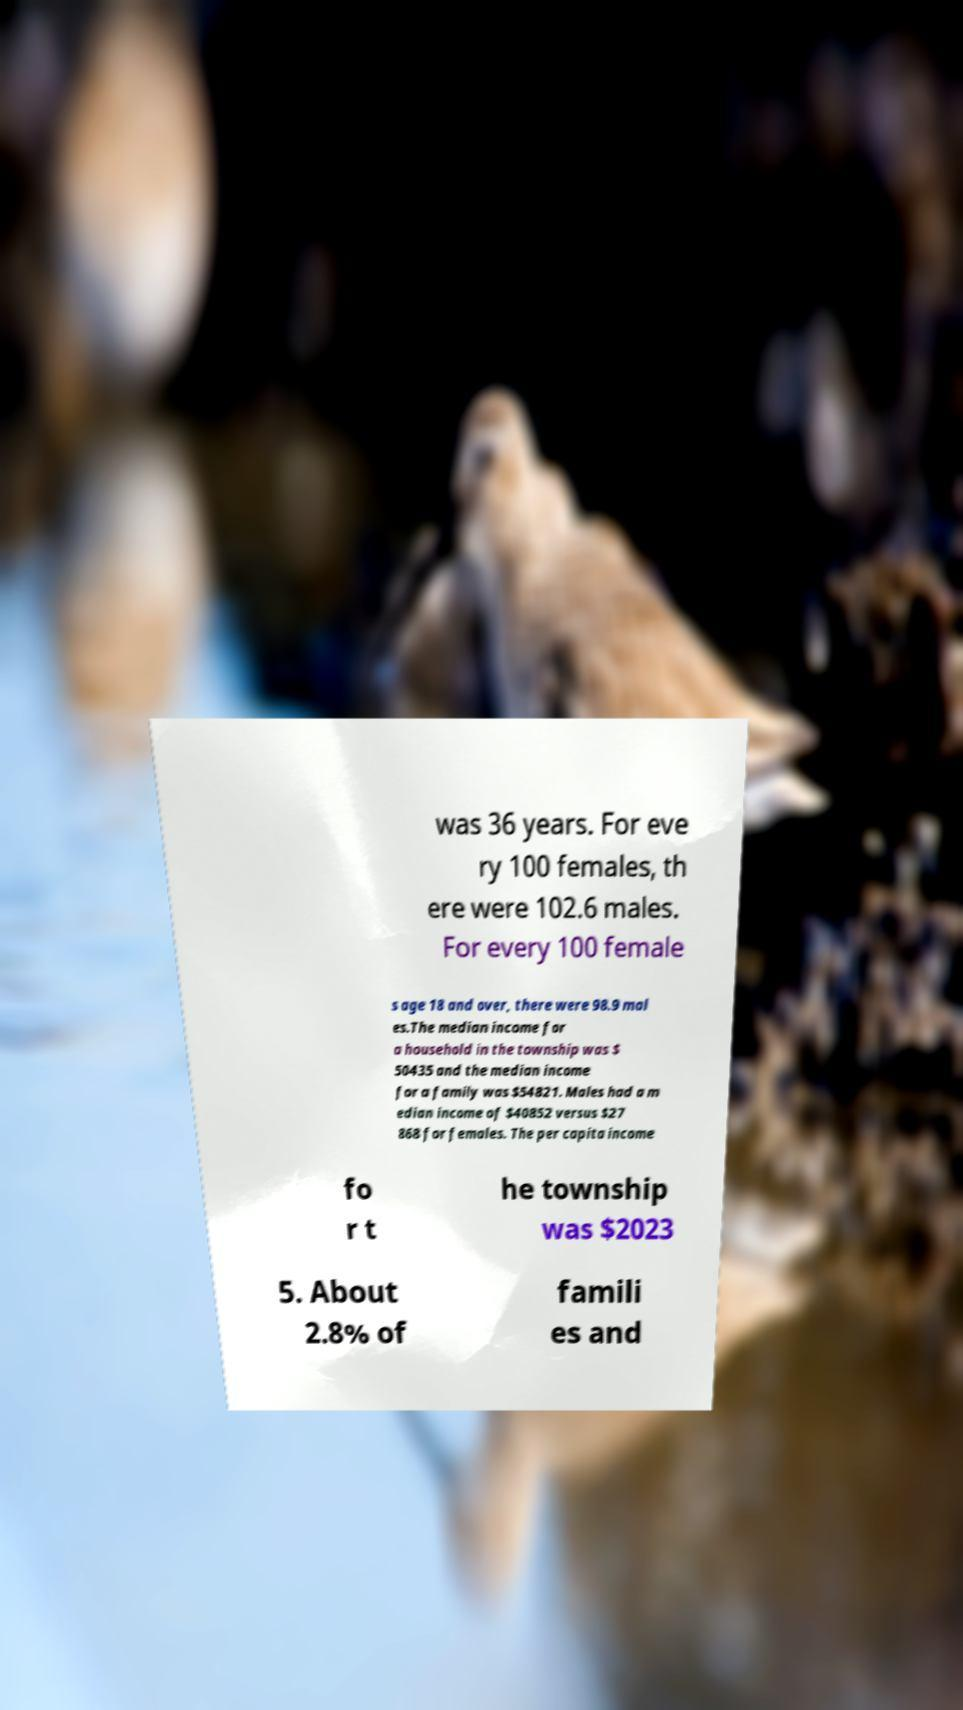Can you read and provide the text displayed in the image?This photo seems to have some interesting text. Can you extract and type it out for me? was 36 years. For eve ry 100 females, th ere were 102.6 males. For every 100 female s age 18 and over, there were 98.9 mal es.The median income for a household in the township was $ 50435 and the median income for a family was $54821. Males had a m edian income of $40852 versus $27 868 for females. The per capita income fo r t he township was $2023 5. About 2.8% of famili es and 